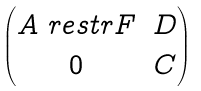Convert formula to latex. <formula><loc_0><loc_0><loc_500><loc_500>\begin{pmatrix} A \ r e s t r F & D \\ 0 & C \end{pmatrix}</formula> 